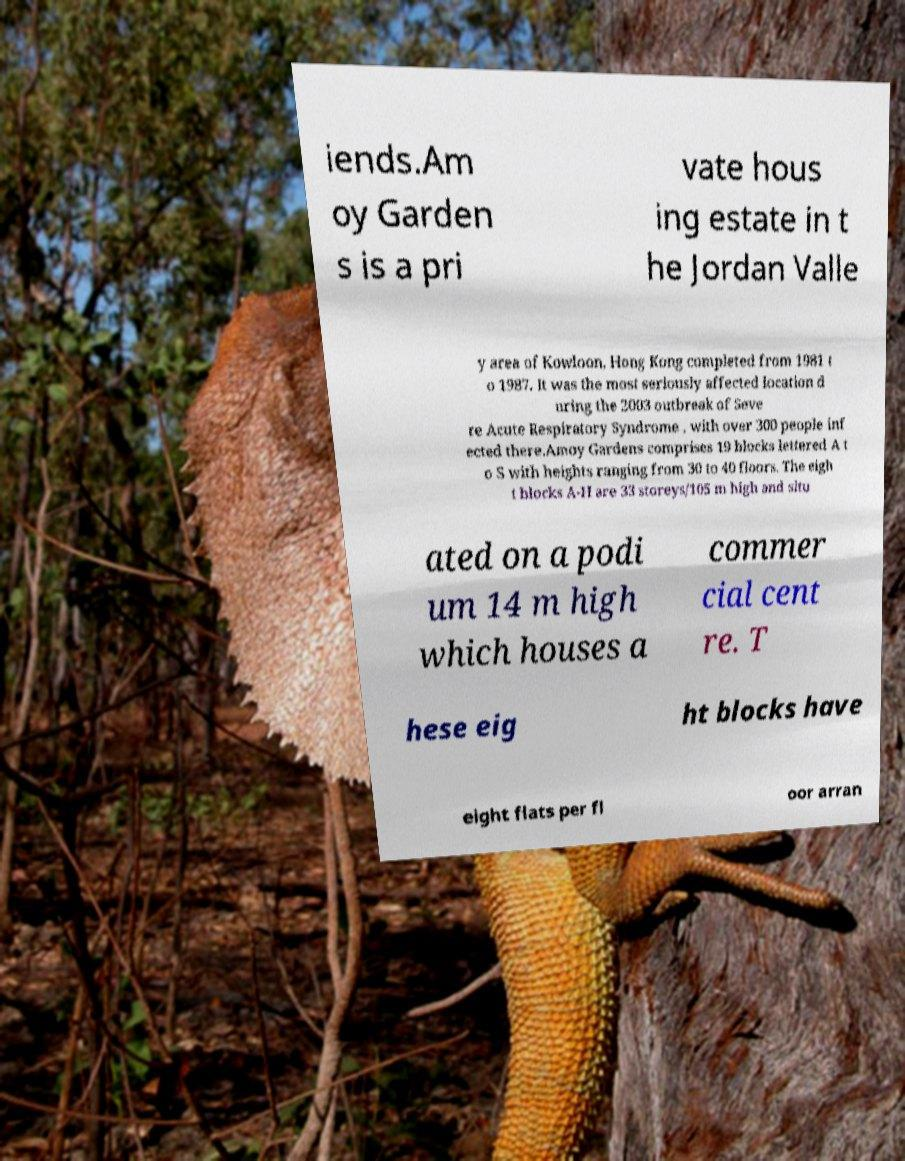Could you extract and type out the text from this image? iends.Am oy Garden s is a pri vate hous ing estate in t he Jordan Valle y area of Kowloon, Hong Kong completed from 1981 t o 1987. It was the most seriously affected location d uring the 2003 outbreak of Seve re Acute Respiratory Syndrome , with over 300 people inf ected there.Amoy Gardens comprises 19 blocks lettered A t o S with heights ranging from 30 to 40 floors. The eigh t blocks A-H are 33 storeys/105 m high and situ ated on a podi um 14 m high which houses a commer cial cent re. T hese eig ht blocks have eight flats per fl oor arran 